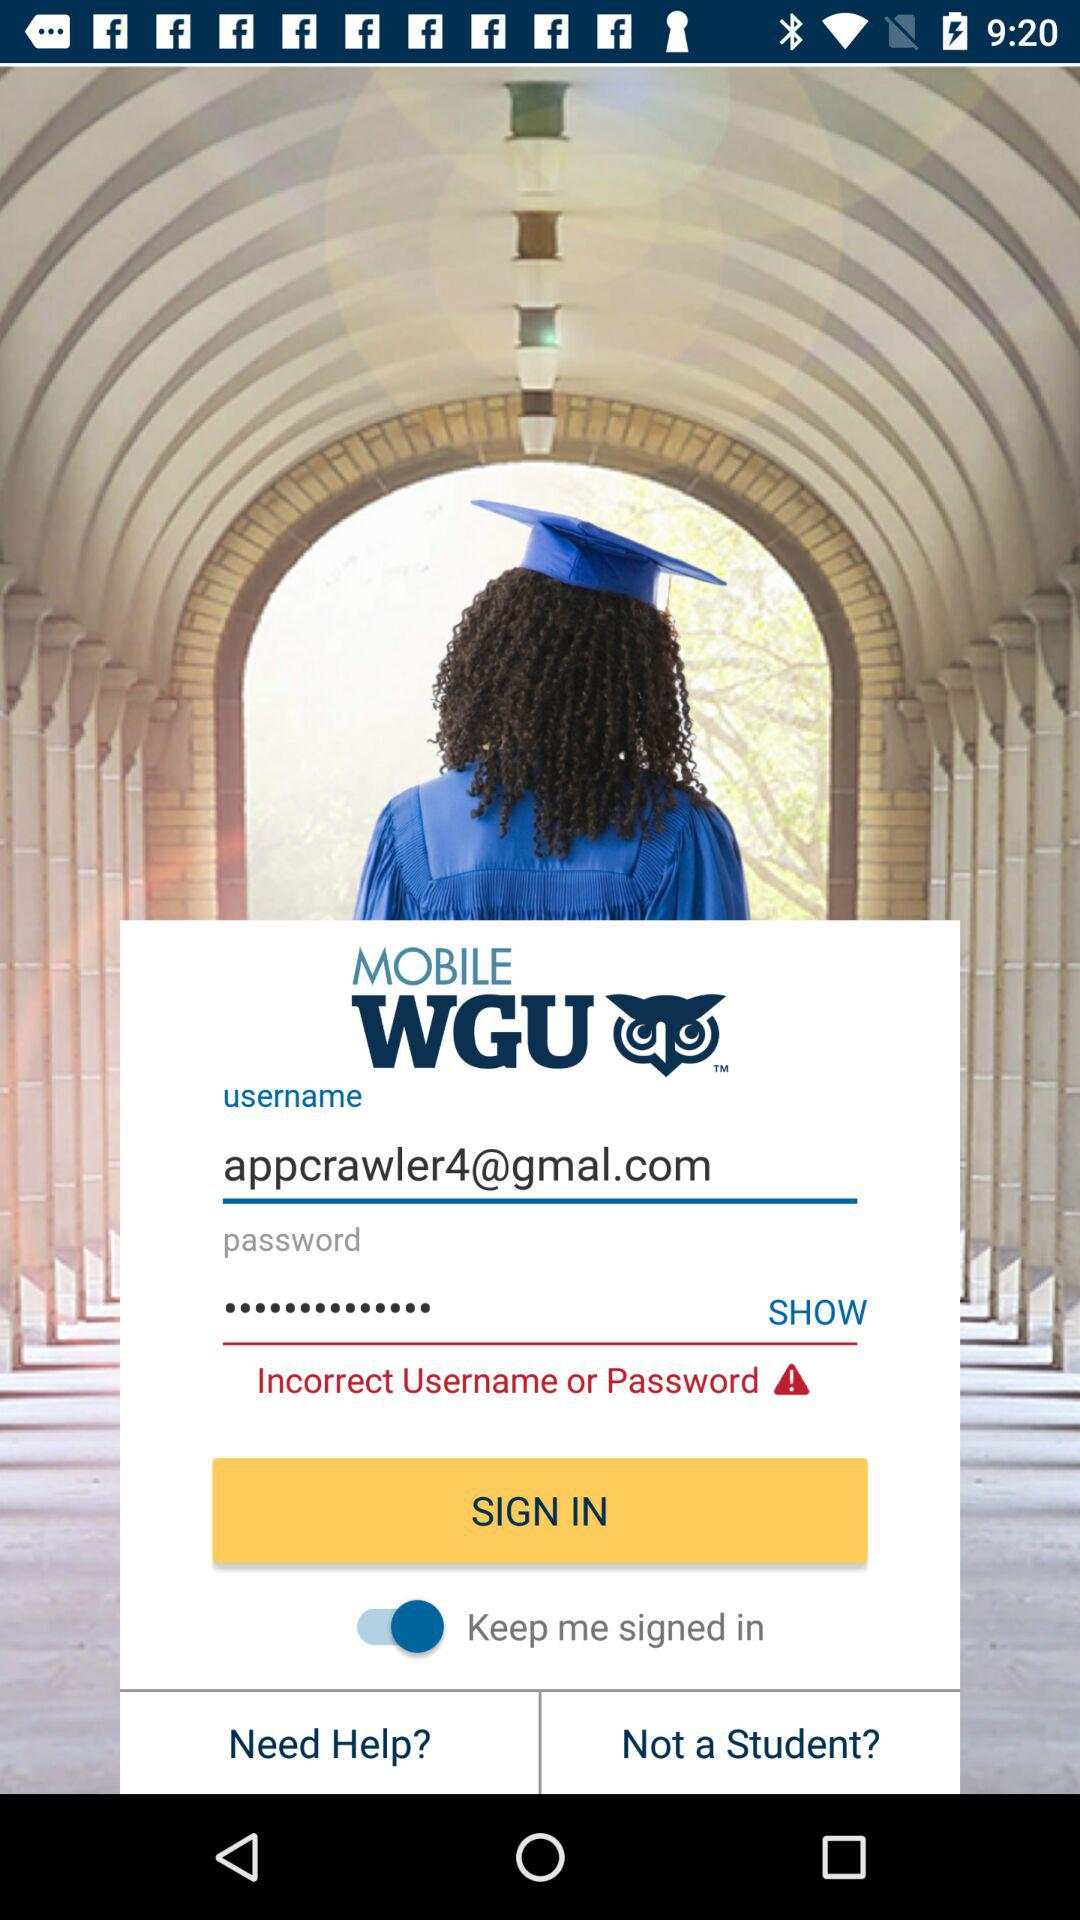How do non-students log in?
When the provided information is insufficient, respond with <no answer>. <no answer> 